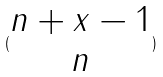Convert formula to latex. <formula><loc_0><loc_0><loc_500><loc_500>( \begin{matrix} n + x - 1 \\ n \end{matrix} )</formula> 